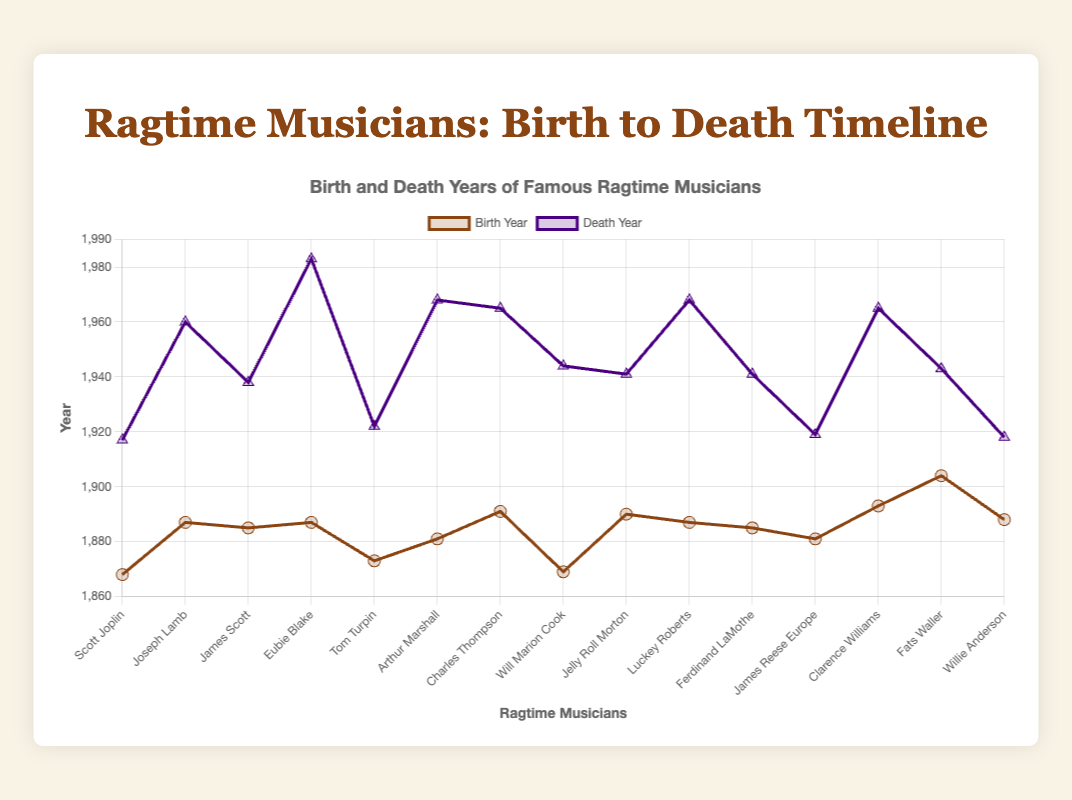What is the birth year of Scott Joplin? Scott Joplin's birth year is plotted on the graph, and you can see it is represented by a point marked on the year axis close to 1868.
Answer: 1868 Which musician lived the longest? By examining both the birth and death year points of each musician, Eubie Blake's death year extends the furthest right before 1983, and his birth year is around 1887. Most other musicians have shorter lifespans.
Answer: Eubie Blake Which two musicians were born in the same year but died in different years? By checking the birth years on the graph, Eubie Blake and Joseph Lamb were both born around 1887. However, their death years show as different, with Eubie Blake dying around 1983 and Joseph Lamb around 1960.
Answer: Eubie Blake and Joseph Lamb In which year did the first of these famous ragtime musicians die? Looking at the death years, Scott Joplin's death year, 1917, is the earliest indicated on the timeline.
Answer: 1917 How many musicians died between 1940 and 1960? Inspecting the death year markers, we see deaths for Jelly Roll Morton (1941), Ferdinand LaMothe (1941), Will Marion Cook (1944), James Scott (1938), and Joseph Lamb (1960). Count only those within the specified range.
Answer: 5 Who was the most recent musician born in the 20th century and what is their birth year? Fats Waller appears as the last entry born after 1900, specifically around 1904.
Answer: Fats Waller, 1904 What is the average birth year of all the musicians shown? To find the average, sum the birth years of all musicians and divide by the number of musicians. The birth years are 1868, 1887, 1885, 1887, 1873, 1881, 1891, 1869, 1890, 1887, 1885, 1881, 1893, 1904, and 1888. Calculate (sum = 24829) / (total = 15).
Answer: 1885.3 Who died in the same year and what year was it? From the graph, Jelly Roll Morton and Ferdinand LaMothe both have death markers at the same year, around 1941.
Answer: Jelly Roll Morton and Ferdinand LaMothe, 1941 How many years did Clarence Williams live? Locate the birth year (around 1893) and death year (around 1965) of Clarence Williams. Subtract birth year from death year to get the lifespan.
Answer: 72 years Which musician has the shortest lifespan in the dataset? By comparing all lifespans, Willie Anderson, whose birth year is around 1888 and death year is around 1918, lived approximately 30 years, the shortest among all listed musicians.
Answer: Willie Anderson 